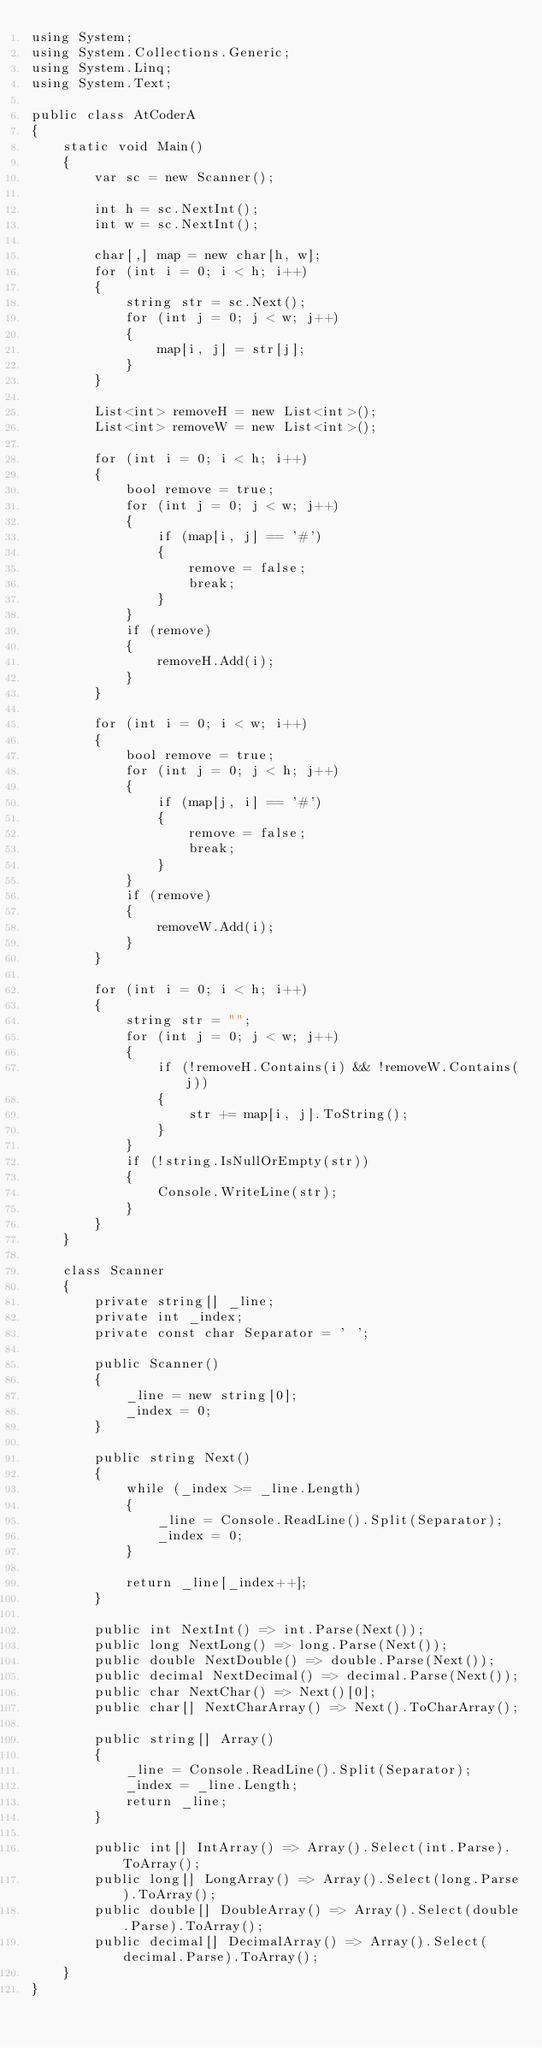<code> <loc_0><loc_0><loc_500><loc_500><_C#_>using System;
using System.Collections.Generic;
using System.Linq;
using System.Text;

public class AtCoderA
{
    static void Main()
    {
        var sc = new Scanner();

        int h = sc.NextInt();
        int w = sc.NextInt();

        char[,] map = new char[h, w];
        for (int i = 0; i < h; i++)
        {
            string str = sc.Next();
            for (int j = 0; j < w; j++)
            {
                map[i, j] = str[j];
            }
        }

        List<int> removeH = new List<int>();
        List<int> removeW = new List<int>();

        for (int i = 0; i < h; i++)
        {
            bool remove = true;
            for (int j = 0; j < w; j++)
            {
                if (map[i, j] == '#')
                {
                    remove = false;
                    break;
                }
            }
            if (remove)
            {
                removeH.Add(i);
            }
        }

        for (int i = 0; i < w; i++)
        {
            bool remove = true;
            for (int j = 0; j < h; j++)
            {
                if (map[j, i] == '#')
                {
                    remove = false;
                    break;
                }
            }
            if (remove)
            {
                removeW.Add(i);
            }
        }

        for (int i = 0; i < h; i++)
        {
            string str = "";
            for (int j = 0; j < w; j++)
            {
                if (!removeH.Contains(i) && !removeW.Contains(j))
                {
                    str += map[i, j].ToString();
                }
            }
            if (!string.IsNullOrEmpty(str))
            {
                Console.WriteLine(str);
            }
        }
    }

    class Scanner
    {
        private string[] _line;
        private int _index;
        private const char Separator = ' ';

        public Scanner()
        {
            _line = new string[0];
            _index = 0;
        }

        public string Next()
        {
            while (_index >= _line.Length)
            {
                _line = Console.ReadLine().Split(Separator);
                _index = 0;
            }

            return _line[_index++];
        }

        public int NextInt() => int.Parse(Next());
        public long NextLong() => long.Parse(Next());
        public double NextDouble() => double.Parse(Next());
        public decimal NextDecimal() => decimal.Parse(Next());
        public char NextChar() => Next()[0];
        public char[] NextCharArray() => Next().ToCharArray();

        public string[] Array()
        {
            _line = Console.ReadLine().Split(Separator);
            _index = _line.Length;
            return _line;
        }

        public int[] IntArray() => Array().Select(int.Parse).ToArray();
        public long[] LongArray() => Array().Select(long.Parse).ToArray();
        public double[] DoubleArray() => Array().Select(double.Parse).ToArray();
        public decimal[] DecimalArray() => Array().Select(decimal.Parse).ToArray();
    }
}</code> 